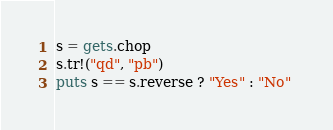<code> <loc_0><loc_0><loc_500><loc_500><_Ruby_>s = gets.chop
s.tr!("qd", "pb")
puts s == s.reverse ? "Yes" : "No" </code> 